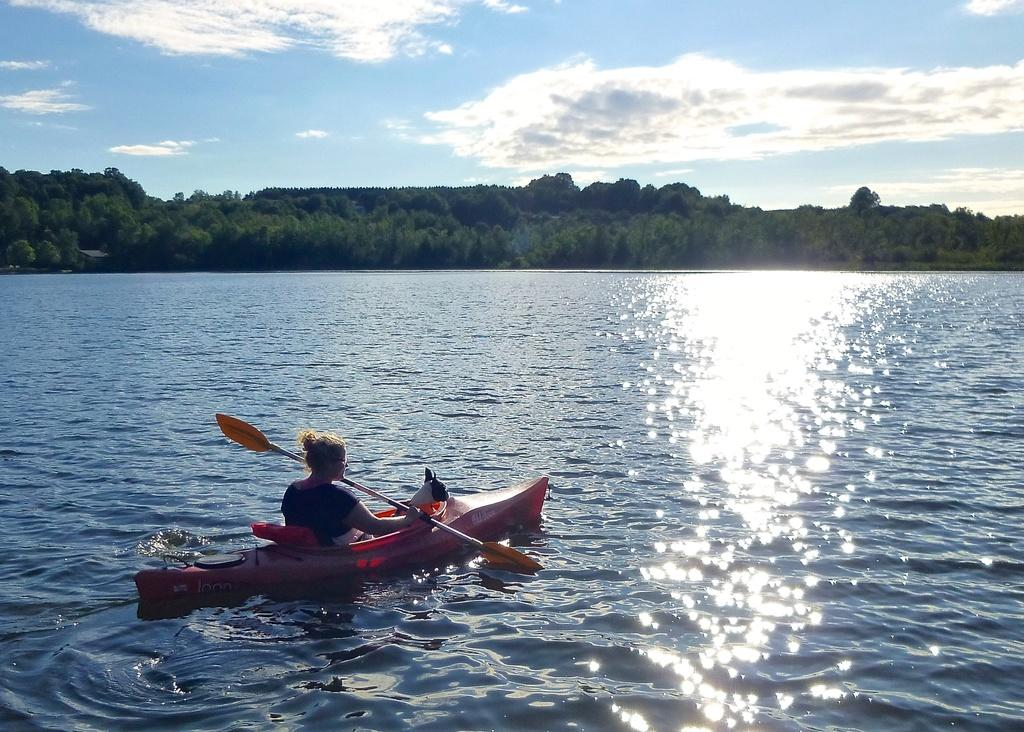What is present in the image that is not solid? There is water in the image. What is the woman doing in the image? The woman is sitting on a boat and rowing the paddle. What else is in the boat with the woman? There is an animal in the boat. What can be seen in the distance in the image? There are trees and the sky visible in the background of the image. How does the woman stretch her legs while rowing in the image? There are no chairs or stretching activities depicted in the image. The woman is sitting on a boat and rowing the paddle. What type of face does the animal have in the image? There is no face visible on the animal in the image. 